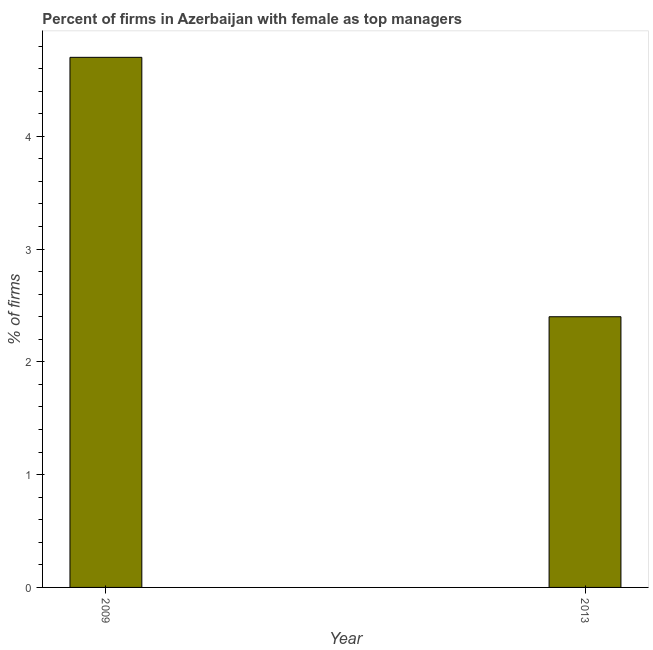What is the title of the graph?
Provide a succinct answer. Percent of firms in Azerbaijan with female as top managers. What is the label or title of the Y-axis?
Your answer should be compact. % of firms. What is the percentage of firms with female as top manager in 2009?
Your answer should be very brief. 4.7. Across all years, what is the maximum percentage of firms with female as top manager?
Keep it short and to the point. 4.7. Across all years, what is the minimum percentage of firms with female as top manager?
Make the answer very short. 2.4. In which year was the percentage of firms with female as top manager maximum?
Provide a short and direct response. 2009. In which year was the percentage of firms with female as top manager minimum?
Provide a short and direct response. 2013. What is the sum of the percentage of firms with female as top manager?
Offer a terse response. 7.1. What is the average percentage of firms with female as top manager per year?
Offer a terse response. 3.55. What is the median percentage of firms with female as top manager?
Offer a very short reply. 3.55. In how many years, is the percentage of firms with female as top manager greater than 3 %?
Keep it short and to the point. 1. Do a majority of the years between 2009 and 2013 (inclusive) have percentage of firms with female as top manager greater than 0.8 %?
Make the answer very short. Yes. What is the ratio of the percentage of firms with female as top manager in 2009 to that in 2013?
Keep it short and to the point. 1.96. Is the percentage of firms with female as top manager in 2009 less than that in 2013?
Ensure brevity in your answer.  No. In how many years, is the percentage of firms with female as top manager greater than the average percentage of firms with female as top manager taken over all years?
Make the answer very short. 1. What is the difference between two consecutive major ticks on the Y-axis?
Keep it short and to the point. 1. Are the values on the major ticks of Y-axis written in scientific E-notation?
Keep it short and to the point. No. What is the % of firms in 2013?
Ensure brevity in your answer.  2.4. What is the ratio of the % of firms in 2009 to that in 2013?
Keep it short and to the point. 1.96. 